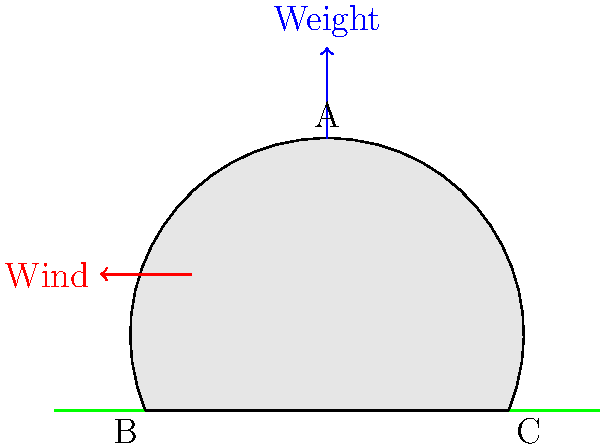In the vector diagram of an ancient Californian cone-shaped dwelling, what primary force distribution principle is demonstrated by the structure's shape in relation to environmental factors? To answer this question, let's analyze the force distribution in the cone-shaped dwelling:

1. The cone shape of the dwelling is crucial for its stability and resistance to environmental forces.

2. Weight force:
   - Represented by the blue arrow pointing downward from point A.
   - The cone shape distributes the weight evenly along its sides to points B and C on the ground.
   - This even distribution prevents localized stress points.

3. Wind force:
   - Represented by the red arrow pointing horizontally.
   - The sloped sides of the cone deflect wind upward, reducing the direct force on the structure.
   - This aerodynamic shape minimizes wind resistance and potential damage.

4. Force distribution:
   - The cone shape effectively transfers both weight and wind forces to the ground.
   - The wide base (BC) provides stability against overturning moments caused by wind.

5. Structural integrity:
   - The cone shape inherently creates a stable structure with no weak points.
   - It mimics natural formations like mountains, which are known for their stability.

The primary force distribution principle demonstrated here is the use of a conical shape to evenly distribute vertical loads while minimizing horizontal wind forces, creating a stable and environmentally adaptive structure.
Answer: Conical force distribution for stability and wind resistance 